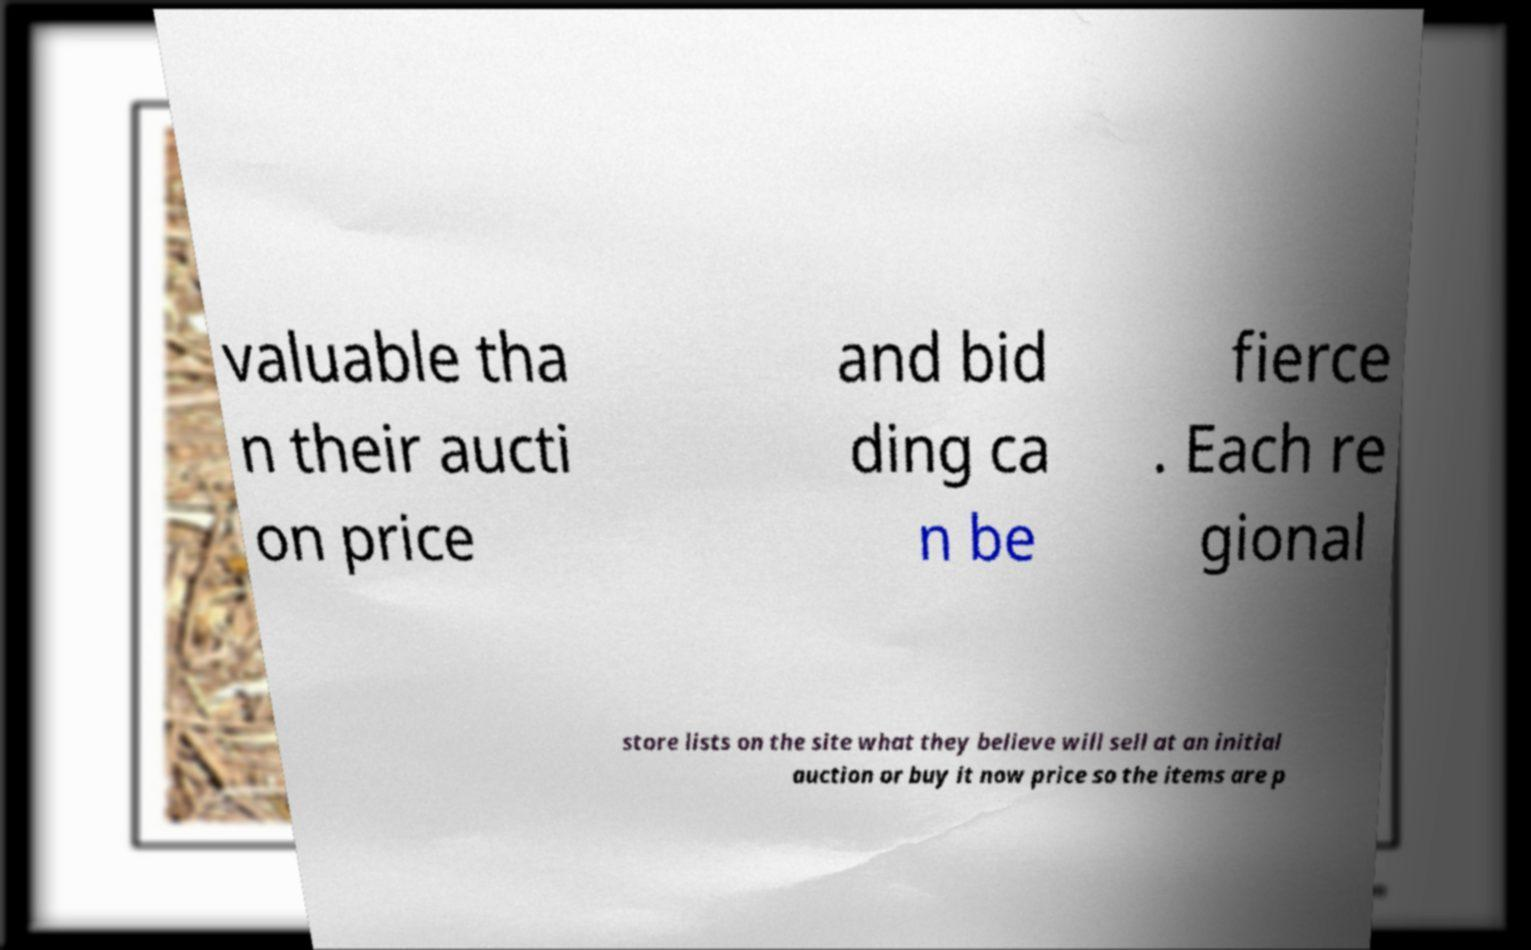I need the written content from this picture converted into text. Can you do that? valuable tha n their aucti on price and bid ding ca n be fierce . Each re gional store lists on the site what they believe will sell at an initial auction or buy it now price so the items are p 